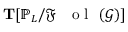Convert formula to latex. <formula><loc_0><loc_0><loc_500><loc_500>T [ \mathbb { P } _ { L } / { \mathfrak { F } { o l } } ( \mathcal { G } ) ]</formula> 